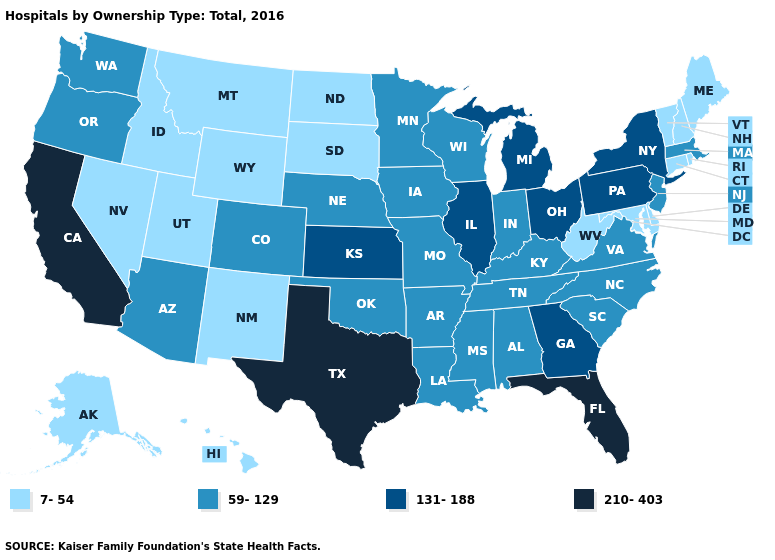Among the states that border Idaho , does Nevada have the lowest value?
Give a very brief answer. Yes. What is the value of New Hampshire?
Give a very brief answer. 7-54. Does the map have missing data?
Answer briefly. No. Does Oklahoma have a higher value than Arkansas?
Write a very short answer. No. Name the states that have a value in the range 131-188?
Short answer required. Georgia, Illinois, Kansas, Michigan, New York, Ohio, Pennsylvania. What is the value of Georgia?
Short answer required. 131-188. What is the highest value in the South ?
Give a very brief answer. 210-403. Name the states that have a value in the range 7-54?
Keep it brief. Alaska, Connecticut, Delaware, Hawaii, Idaho, Maine, Maryland, Montana, Nevada, New Hampshire, New Mexico, North Dakota, Rhode Island, South Dakota, Utah, Vermont, West Virginia, Wyoming. What is the value of Washington?
Quick response, please. 59-129. Does the first symbol in the legend represent the smallest category?
Short answer required. Yes. What is the highest value in states that border Kansas?
Short answer required. 59-129. Among the states that border Arkansas , does Mississippi have the highest value?
Be succinct. No. What is the lowest value in the USA?
Keep it brief. 7-54. Does Michigan have the highest value in the MidWest?
Concise answer only. Yes. What is the value of New York?
Write a very short answer. 131-188. 